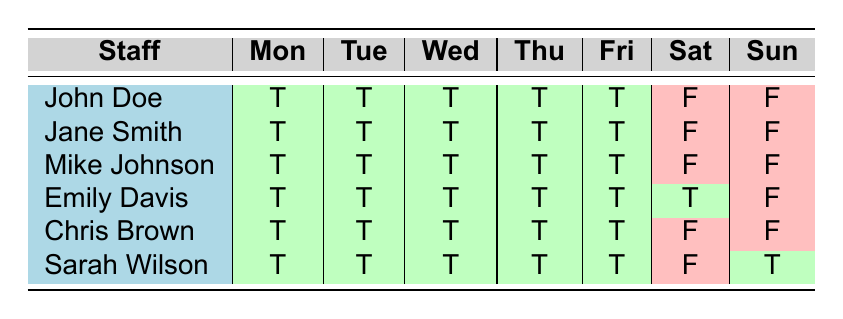What days is John Doe available to work? John Doe is marked as available (T) for Monday, Tuesday, Wednesday, Thursday, and Friday in the table. He is marked as unavailable (F) for Saturday and Sunday.
Answer: Monday, Tuesday, Wednesday, Thursday, Friday How many total hours is Emily Davis available on the weekend? Emily Davis is only available on Saturday according to the table. Her Saturday hours are from 09:00 to 14:00, which totals 5 hours. She is not available on Sunday.
Answer: 5 hours Is Sarah Wilson available on Sunday? The table shows that Sarah Wilson is marked as available (T) on Sunday. Therefore, she is indeed available on that day.
Answer: Yes Which staff member has the highest workload? The workload values are: John Doe (30), Jane Smith (25), Mike Johnson (35), Emily Davis (20), Chris Brown (15), and Sarah Wilson (28). Mike Johnson has the highest workload at 35.
Answer: Mike Johnson What is the total workload of all mechanics? The mechanics listed are John Doe (30), Mike Johnson (35), and Sarah Wilson (28). To find the total workload of mechanics, we sum these values: 30 + 35 + 28 = 93.
Answer: 93 Are there any staff members available on Saturday? The table indicates that Emily Davis is available on Saturday while all other staff members are marked as unavailable (F). Therefore, Emily Davis is the only one available on that day.
Answer: Yes On which day is Chris Brown unavailable? According to the table, Chris Brown is marked as available (T) for Monday through Friday and marked as unavailable (F) for Saturday and Sunday.
Answer: Saturday and Sunday What is the average workload for the staff members? The total workloads are: John Doe (30), Jane Smith (25), Mike Johnson (35), Emily Davis (20), Chris Brown (15), and Sarah Wilson (28). The total workload is 30 + 25 + 35 + 20 + 15 + 28 = 153. There are 6 staff members, so the average is 153 / 6 = 25.5.
Answer: 25.5 How many days in total is Mike Johnson available? The table shows that Mike Johnson is available (T) on every weekday (Monday to Friday), but he is unavailable (F) on Saturday and Sunday. This totals to 5 days of availability.
Answer: 5 days 